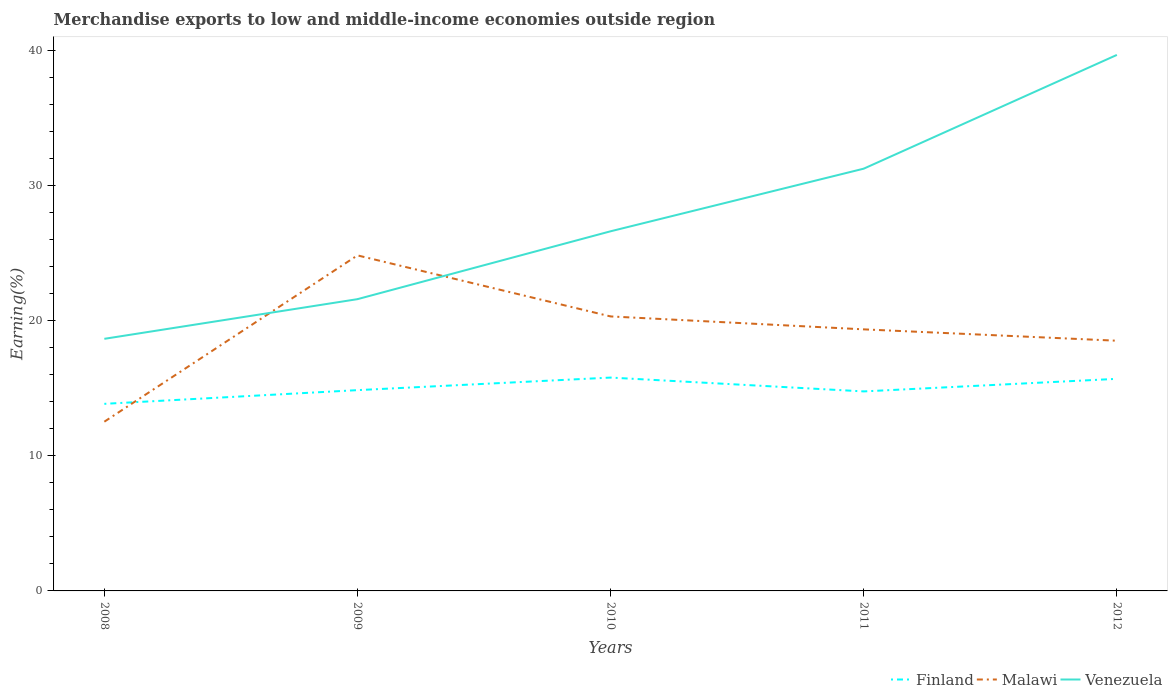How many different coloured lines are there?
Give a very brief answer. 3. Is the number of lines equal to the number of legend labels?
Make the answer very short. Yes. Across all years, what is the maximum percentage of amount earned from merchandise exports in Malawi?
Keep it short and to the point. 12.53. What is the total percentage of amount earned from merchandise exports in Finland in the graph?
Your answer should be compact. 0.09. What is the difference between the highest and the second highest percentage of amount earned from merchandise exports in Venezuela?
Provide a succinct answer. 21.01. What is the difference between the highest and the lowest percentage of amount earned from merchandise exports in Venezuela?
Ensure brevity in your answer.  2. Are the values on the major ticks of Y-axis written in scientific E-notation?
Ensure brevity in your answer.  No. Does the graph contain any zero values?
Your answer should be very brief. No. Where does the legend appear in the graph?
Provide a succinct answer. Bottom right. What is the title of the graph?
Make the answer very short. Merchandise exports to low and middle-income economies outside region. What is the label or title of the X-axis?
Offer a very short reply. Years. What is the label or title of the Y-axis?
Provide a short and direct response. Earning(%). What is the Earning(%) in Finland in 2008?
Provide a succinct answer. 13.85. What is the Earning(%) in Malawi in 2008?
Your response must be concise. 12.53. What is the Earning(%) in Venezuela in 2008?
Ensure brevity in your answer.  18.66. What is the Earning(%) in Finland in 2009?
Keep it short and to the point. 14.86. What is the Earning(%) of Malawi in 2009?
Offer a very short reply. 24.84. What is the Earning(%) in Venezuela in 2009?
Make the answer very short. 21.6. What is the Earning(%) of Finland in 2010?
Keep it short and to the point. 15.79. What is the Earning(%) of Malawi in 2010?
Keep it short and to the point. 20.32. What is the Earning(%) in Venezuela in 2010?
Your answer should be very brief. 26.62. What is the Earning(%) of Finland in 2011?
Keep it short and to the point. 14.77. What is the Earning(%) in Malawi in 2011?
Make the answer very short. 19.36. What is the Earning(%) of Venezuela in 2011?
Your response must be concise. 31.26. What is the Earning(%) in Finland in 2012?
Your answer should be compact. 15.7. What is the Earning(%) in Malawi in 2012?
Provide a succinct answer. 18.52. What is the Earning(%) in Venezuela in 2012?
Make the answer very short. 39.67. Across all years, what is the maximum Earning(%) of Finland?
Make the answer very short. 15.79. Across all years, what is the maximum Earning(%) in Malawi?
Provide a succinct answer. 24.84. Across all years, what is the maximum Earning(%) in Venezuela?
Ensure brevity in your answer.  39.67. Across all years, what is the minimum Earning(%) of Finland?
Your answer should be very brief. 13.85. Across all years, what is the minimum Earning(%) of Malawi?
Provide a succinct answer. 12.53. Across all years, what is the minimum Earning(%) of Venezuela?
Keep it short and to the point. 18.66. What is the total Earning(%) in Finland in the graph?
Your response must be concise. 74.97. What is the total Earning(%) in Malawi in the graph?
Your answer should be compact. 95.56. What is the total Earning(%) of Venezuela in the graph?
Give a very brief answer. 137.81. What is the difference between the Earning(%) in Finland in 2008 and that in 2009?
Make the answer very short. -1.01. What is the difference between the Earning(%) in Malawi in 2008 and that in 2009?
Offer a very short reply. -12.31. What is the difference between the Earning(%) in Venezuela in 2008 and that in 2009?
Ensure brevity in your answer.  -2.94. What is the difference between the Earning(%) of Finland in 2008 and that in 2010?
Your answer should be compact. -1.94. What is the difference between the Earning(%) in Malawi in 2008 and that in 2010?
Offer a very short reply. -7.79. What is the difference between the Earning(%) in Venezuela in 2008 and that in 2010?
Keep it short and to the point. -7.96. What is the difference between the Earning(%) in Finland in 2008 and that in 2011?
Give a very brief answer. -0.92. What is the difference between the Earning(%) in Malawi in 2008 and that in 2011?
Ensure brevity in your answer.  -6.83. What is the difference between the Earning(%) of Venezuela in 2008 and that in 2011?
Give a very brief answer. -12.59. What is the difference between the Earning(%) in Finland in 2008 and that in 2012?
Give a very brief answer. -1.85. What is the difference between the Earning(%) of Malawi in 2008 and that in 2012?
Your answer should be compact. -5.99. What is the difference between the Earning(%) in Venezuela in 2008 and that in 2012?
Ensure brevity in your answer.  -21.01. What is the difference between the Earning(%) of Finland in 2009 and that in 2010?
Make the answer very short. -0.93. What is the difference between the Earning(%) of Malawi in 2009 and that in 2010?
Offer a terse response. 4.52. What is the difference between the Earning(%) of Venezuela in 2009 and that in 2010?
Your answer should be compact. -5.02. What is the difference between the Earning(%) of Finland in 2009 and that in 2011?
Provide a succinct answer. 0.09. What is the difference between the Earning(%) in Malawi in 2009 and that in 2011?
Your response must be concise. 5.48. What is the difference between the Earning(%) in Venezuela in 2009 and that in 2011?
Your answer should be compact. -9.66. What is the difference between the Earning(%) of Finland in 2009 and that in 2012?
Ensure brevity in your answer.  -0.84. What is the difference between the Earning(%) in Malawi in 2009 and that in 2012?
Your response must be concise. 6.32. What is the difference between the Earning(%) in Venezuela in 2009 and that in 2012?
Make the answer very short. -18.08. What is the difference between the Earning(%) of Malawi in 2010 and that in 2011?
Keep it short and to the point. 0.96. What is the difference between the Earning(%) in Venezuela in 2010 and that in 2011?
Provide a short and direct response. -4.63. What is the difference between the Earning(%) in Finland in 2010 and that in 2012?
Your response must be concise. 0.09. What is the difference between the Earning(%) of Malawi in 2010 and that in 2012?
Give a very brief answer. 1.8. What is the difference between the Earning(%) in Venezuela in 2010 and that in 2012?
Offer a very short reply. -13.05. What is the difference between the Earning(%) of Finland in 2011 and that in 2012?
Give a very brief answer. -0.93. What is the difference between the Earning(%) of Malawi in 2011 and that in 2012?
Provide a succinct answer. 0.84. What is the difference between the Earning(%) of Venezuela in 2011 and that in 2012?
Make the answer very short. -8.42. What is the difference between the Earning(%) in Finland in 2008 and the Earning(%) in Malawi in 2009?
Ensure brevity in your answer.  -10.99. What is the difference between the Earning(%) in Finland in 2008 and the Earning(%) in Venezuela in 2009?
Your answer should be compact. -7.75. What is the difference between the Earning(%) in Malawi in 2008 and the Earning(%) in Venezuela in 2009?
Your response must be concise. -9.07. What is the difference between the Earning(%) of Finland in 2008 and the Earning(%) of Malawi in 2010?
Make the answer very short. -6.47. What is the difference between the Earning(%) of Finland in 2008 and the Earning(%) of Venezuela in 2010?
Your answer should be compact. -12.77. What is the difference between the Earning(%) of Malawi in 2008 and the Earning(%) of Venezuela in 2010?
Offer a terse response. -14.09. What is the difference between the Earning(%) of Finland in 2008 and the Earning(%) of Malawi in 2011?
Your response must be concise. -5.51. What is the difference between the Earning(%) in Finland in 2008 and the Earning(%) in Venezuela in 2011?
Give a very brief answer. -17.41. What is the difference between the Earning(%) in Malawi in 2008 and the Earning(%) in Venezuela in 2011?
Keep it short and to the point. -18.73. What is the difference between the Earning(%) of Finland in 2008 and the Earning(%) of Malawi in 2012?
Your answer should be compact. -4.67. What is the difference between the Earning(%) in Finland in 2008 and the Earning(%) in Venezuela in 2012?
Give a very brief answer. -25.83. What is the difference between the Earning(%) in Malawi in 2008 and the Earning(%) in Venezuela in 2012?
Keep it short and to the point. -27.15. What is the difference between the Earning(%) of Finland in 2009 and the Earning(%) of Malawi in 2010?
Keep it short and to the point. -5.46. What is the difference between the Earning(%) of Finland in 2009 and the Earning(%) of Venezuela in 2010?
Make the answer very short. -11.76. What is the difference between the Earning(%) of Malawi in 2009 and the Earning(%) of Venezuela in 2010?
Your answer should be very brief. -1.78. What is the difference between the Earning(%) in Finland in 2009 and the Earning(%) in Malawi in 2011?
Make the answer very short. -4.5. What is the difference between the Earning(%) in Finland in 2009 and the Earning(%) in Venezuela in 2011?
Your answer should be very brief. -16.39. What is the difference between the Earning(%) in Malawi in 2009 and the Earning(%) in Venezuela in 2011?
Keep it short and to the point. -6.42. What is the difference between the Earning(%) in Finland in 2009 and the Earning(%) in Malawi in 2012?
Make the answer very short. -3.66. What is the difference between the Earning(%) in Finland in 2009 and the Earning(%) in Venezuela in 2012?
Provide a succinct answer. -24.81. What is the difference between the Earning(%) of Malawi in 2009 and the Earning(%) of Venezuela in 2012?
Give a very brief answer. -14.84. What is the difference between the Earning(%) in Finland in 2010 and the Earning(%) in Malawi in 2011?
Your response must be concise. -3.57. What is the difference between the Earning(%) in Finland in 2010 and the Earning(%) in Venezuela in 2011?
Make the answer very short. -15.46. What is the difference between the Earning(%) of Malawi in 2010 and the Earning(%) of Venezuela in 2011?
Your answer should be very brief. -10.94. What is the difference between the Earning(%) of Finland in 2010 and the Earning(%) of Malawi in 2012?
Ensure brevity in your answer.  -2.73. What is the difference between the Earning(%) in Finland in 2010 and the Earning(%) in Venezuela in 2012?
Provide a short and direct response. -23.88. What is the difference between the Earning(%) of Malawi in 2010 and the Earning(%) of Venezuela in 2012?
Give a very brief answer. -19.36. What is the difference between the Earning(%) in Finland in 2011 and the Earning(%) in Malawi in 2012?
Give a very brief answer. -3.75. What is the difference between the Earning(%) of Finland in 2011 and the Earning(%) of Venezuela in 2012?
Ensure brevity in your answer.  -24.91. What is the difference between the Earning(%) in Malawi in 2011 and the Earning(%) in Venezuela in 2012?
Ensure brevity in your answer.  -20.31. What is the average Earning(%) in Finland per year?
Provide a short and direct response. 14.99. What is the average Earning(%) in Malawi per year?
Offer a very short reply. 19.11. What is the average Earning(%) of Venezuela per year?
Your answer should be compact. 27.56. In the year 2008, what is the difference between the Earning(%) of Finland and Earning(%) of Malawi?
Your answer should be compact. 1.32. In the year 2008, what is the difference between the Earning(%) of Finland and Earning(%) of Venezuela?
Provide a short and direct response. -4.81. In the year 2008, what is the difference between the Earning(%) of Malawi and Earning(%) of Venezuela?
Ensure brevity in your answer.  -6.13. In the year 2009, what is the difference between the Earning(%) of Finland and Earning(%) of Malawi?
Ensure brevity in your answer.  -9.97. In the year 2009, what is the difference between the Earning(%) in Finland and Earning(%) in Venezuela?
Your answer should be very brief. -6.73. In the year 2009, what is the difference between the Earning(%) in Malawi and Earning(%) in Venezuela?
Ensure brevity in your answer.  3.24. In the year 2010, what is the difference between the Earning(%) of Finland and Earning(%) of Malawi?
Provide a succinct answer. -4.53. In the year 2010, what is the difference between the Earning(%) in Finland and Earning(%) in Venezuela?
Your answer should be very brief. -10.83. In the year 2010, what is the difference between the Earning(%) of Malawi and Earning(%) of Venezuela?
Offer a very short reply. -6.3. In the year 2011, what is the difference between the Earning(%) of Finland and Earning(%) of Malawi?
Offer a terse response. -4.59. In the year 2011, what is the difference between the Earning(%) in Finland and Earning(%) in Venezuela?
Provide a short and direct response. -16.49. In the year 2011, what is the difference between the Earning(%) in Malawi and Earning(%) in Venezuela?
Your response must be concise. -11.89. In the year 2012, what is the difference between the Earning(%) in Finland and Earning(%) in Malawi?
Offer a very short reply. -2.82. In the year 2012, what is the difference between the Earning(%) of Finland and Earning(%) of Venezuela?
Offer a terse response. -23.98. In the year 2012, what is the difference between the Earning(%) of Malawi and Earning(%) of Venezuela?
Your answer should be compact. -21.16. What is the ratio of the Earning(%) of Finland in 2008 to that in 2009?
Your answer should be very brief. 0.93. What is the ratio of the Earning(%) in Malawi in 2008 to that in 2009?
Give a very brief answer. 0.5. What is the ratio of the Earning(%) in Venezuela in 2008 to that in 2009?
Offer a terse response. 0.86. What is the ratio of the Earning(%) of Finland in 2008 to that in 2010?
Make the answer very short. 0.88. What is the ratio of the Earning(%) in Malawi in 2008 to that in 2010?
Your answer should be compact. 0.62. What is the ratio of the Earning(%) in Venezuela in 2008 to that in 2010?
Keep it short and to the point. 0.7. What is the ratio of the Earning(%) in Finland in 2008 to that in 2011?
Offer a terse response. 0.94. What is the ratio of the Earning(%) of Malawi in 2008 to that in 2011?
Make the answer very short. 0.65. What is the ratio of the Earning(%) of Venezuela in 2008 to that in 2011?
Keep it short and to the point. 0.6. What is the ratio of the Earning(%) of Finland in 2008 to that in 2012?
Offer a very short reply. 0.88. What is the ratio of the Earning(%) of Malawi in 2008 to that in 2012?
Give a very brief answer. 0.68. What is the ratio of the Earning(%) in Venezuela in 2008 to that in 2012?
Your answer should be compact. 0.47. What is the ratio of the Earning(%) in Finland in 2009 to that in 2010?
Keep it short and to the point. 0.94. What is the ratio of the Earning(%) of Malawi in 2009 to that in 2010?
Keep it short and to the point. 1.22. What is the ratio of the Earning(%) in Venezuela in 2009 to that in 2010?
Offer a very short reply. 0.81. What is the ratio of the Earning(%) of Finland in 2009 to that in 2011?
Your response must be concise. 1.01. What is the ratio of the Earning(%) in Malawi in 2009 to that in 2011?
Make the answer very short. 1.28. What is the ratio of the Earning(%) of Venezuela in 2009 to that in 2011?
Make the answer very short. 0.69. What is the ratio of the Earning(%) of Finland in 2009 to that in 2012?
Your answer should be compact. 0.95. What is the ratio of the Earning(%) of Malawi in 2009 to that in 2012?
Make the answer very short. 1.34. What is the ratio of the Earning(%) of Venezuela in 2009 to that in 2012?
Give a very brief answer. 0.54. What is the ratio of the Earning(%) in Finland in 2010 to that in 2011?
Offer a terse response. 1.07. What is the ratio of the Earning(%) in Malawi in 2010 to that in 2011?
Your answer should be very brief. 1.05. What is the ratio of the Earning(%) of Venezuela in 2010 to that in 2011?
Provide a succinct answer. 0.85. What is the ratio of the Earning(%) of Finland in 2010 to that in 2012?
Offer a very short reply. 1.01. What is the ratio of the Earning(%) of Malawi in 2010 to that in 2012?
Keep it short and to the point. 1.1. What is the ratio of the Earning(%) of Venezuela in 2010 to that in 2012?
Your response must be concise. 0.67. What is the ratio of the Earning(%) of Finland in 2011 to that in 2012?
Give a very brief answer. 0.94. What is the ratio of the Earning(%) in Malawi in 2011 to that in 2012?
Make the answer very short. 1.05. What is the ratio of the Earning(%) in Venezuela in 2011 to that in 2012?
Your response must be concise. 0.79. What is the difference between the highest and the second highest Earning(%) in Finland?
Make the answer very short. 0.09. What is the difference between the highest and the second highest Earning(%) in Malawi?
Keep it short and to the point. 4.52. What is the difference between the highest and the second highest Earning(%) in Venezuela?
Your answer should be very brief. 8.42. What is the difference between the highest and the lowest Earning(%) in Finland?
Your answer should be compact. 1.94. What is the difference between the highest and the lowest Earning(%) in Malawi?
Offer a very short reply. 12.31. What is the difference between the highest and the lowest Earning(%) of Venezuela?
Your answer should be compact. 21.01. 